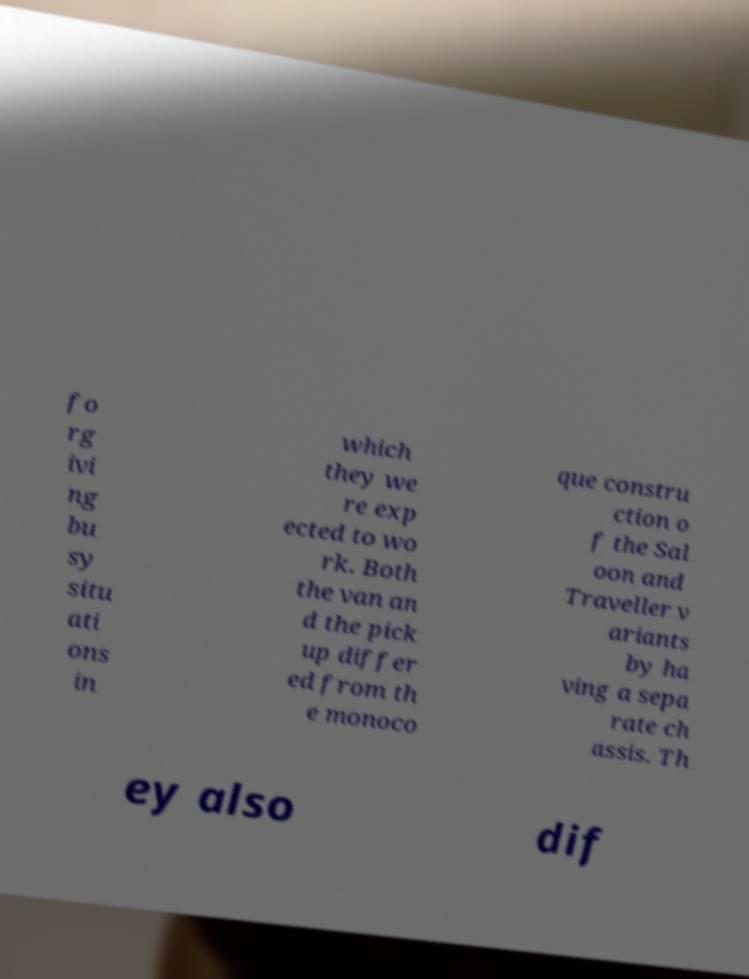Could you assist in decoding the text presented in this image and type it out clearly? fo rg ivi ng bu sy situ ati ons in which they we re exp ected to wo rk. Both the van an d the pick up differ ed from th e monoco que constru ction o f the Sal oon and Traveller v ariants by ha ving a sepa rate ch assis. Th ey also dif 